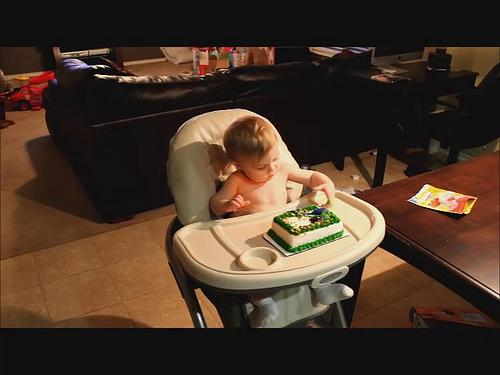Question: where was this photo taken?
Choices:
A. Denny's.
B. McDonald's.
C. At the kitchen table.
D. Hardees.
Answer with the letter. Answer: C Question: why is the photo illuminated?
Choices:
A. In a museum.
B. In a dark room.
C. Picture of the flag.
D. Light fixture.
Answer with the letter. Answer: D Question: when was this photo taken?
Choices:
A. During a storm.
B. At a party.
C. During the day.
D. At a wedding.
Answer with the letter. Answer: C Question: what color is the table?
Choices:
A. Black.
B. Red.
C. Orange.
D. Brown.
Answer with the letter. Answer: D Question: who is in the high chair?
Choices:
A. His big brother.
B. The cat.
C. The baby.
D. Her niece.
Answer with the letter. Answer: C Question: what color is the floor?
Choices:
A. Black.
B. Brown.
C. Tan.
D. White.
Answer with the letter. Answer: C 